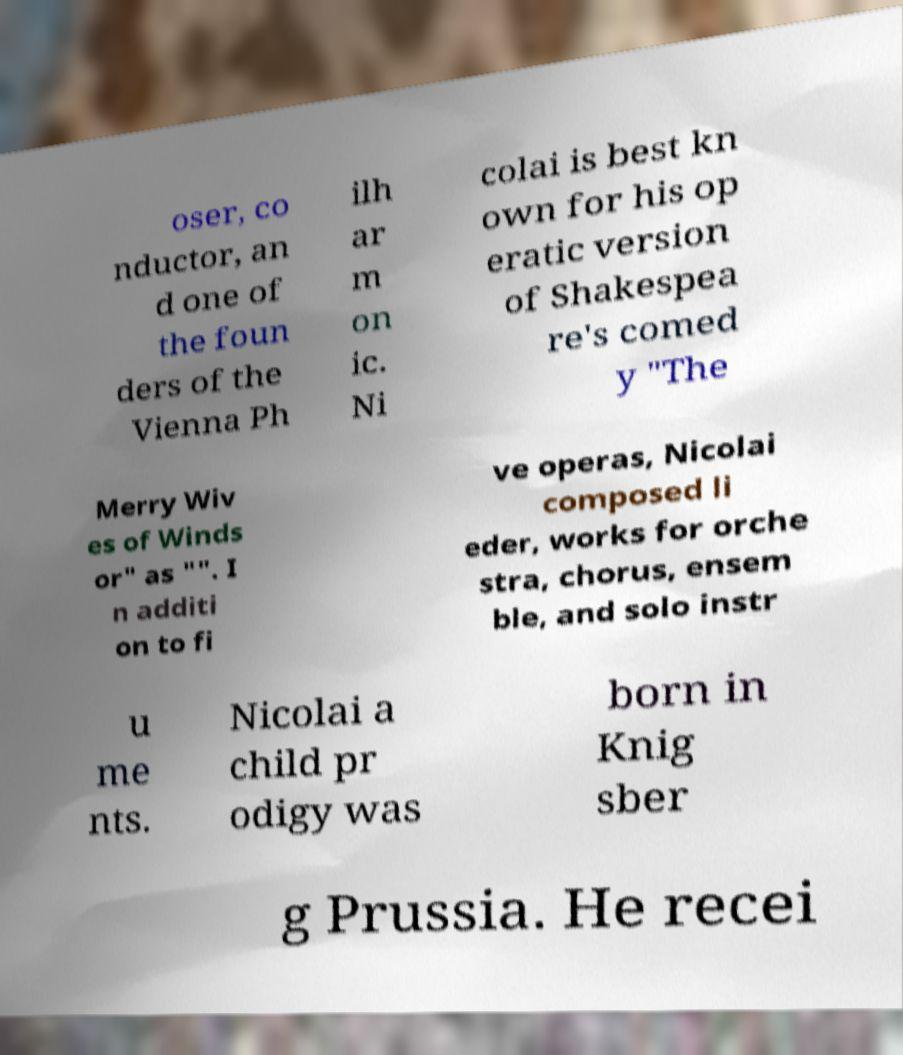Can you read and provide the text displayed in the image?This photo seems to have some interesting text. Can you extract and type it out for me? oser, co nductor, an d one of the foun ders of the Vienna Ph ilh ar m on ic. Ni colai is best kn own for his op eratic version of Shakespea re's comed y "The Merry Wiv es of Winds or" as "". I n additi on to fi ve operas, Nicolai composed li eder, works for orche stra, chorus, ensem ble, and solo instr u me nts. Nicolai a child pr odigy was born in Knig sber g Prussia. He recei 